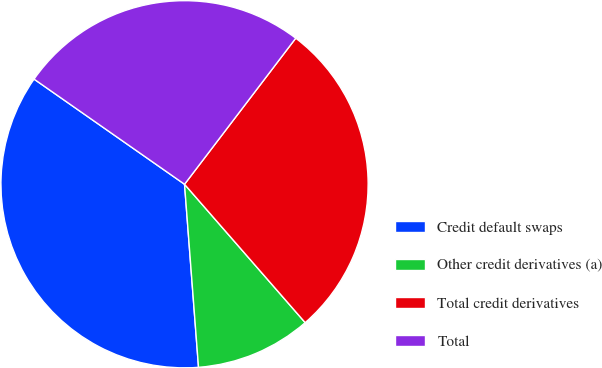<chart> <loc_0><loc_0><loc_500><loc_500><pie_chart><fcel>Credit default swaps<fcel>Other credit derivatives (a)<fcel>Total credit derivatives<fcel>Total<nl><fcel>35.92%<fcel>10.2%<fcel>28.23%<fcel>25.65%<nl></chart> 